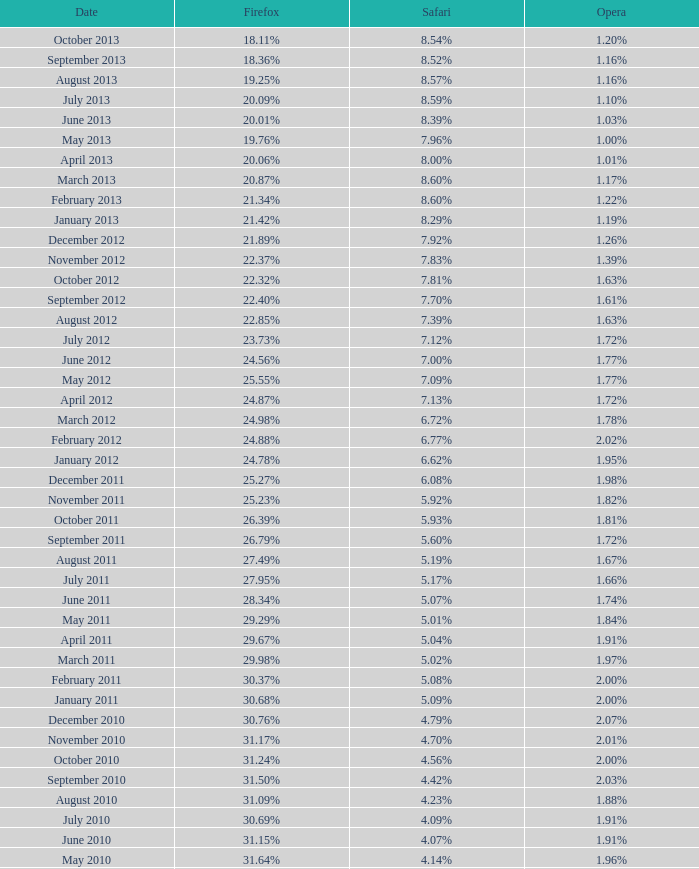What percentage of browsers were using Internet Explorer in April 2009? 61.88%. 